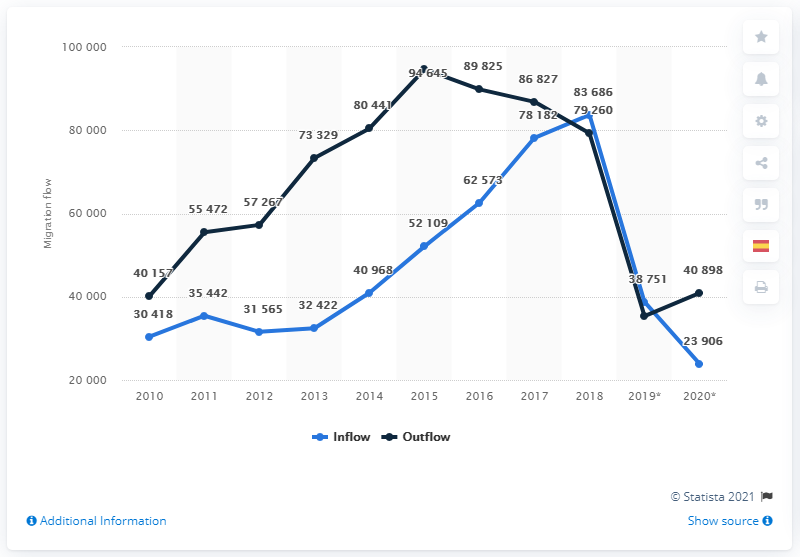In what year did the number of Spaniards returning to Spain begin to fall?
 2016 